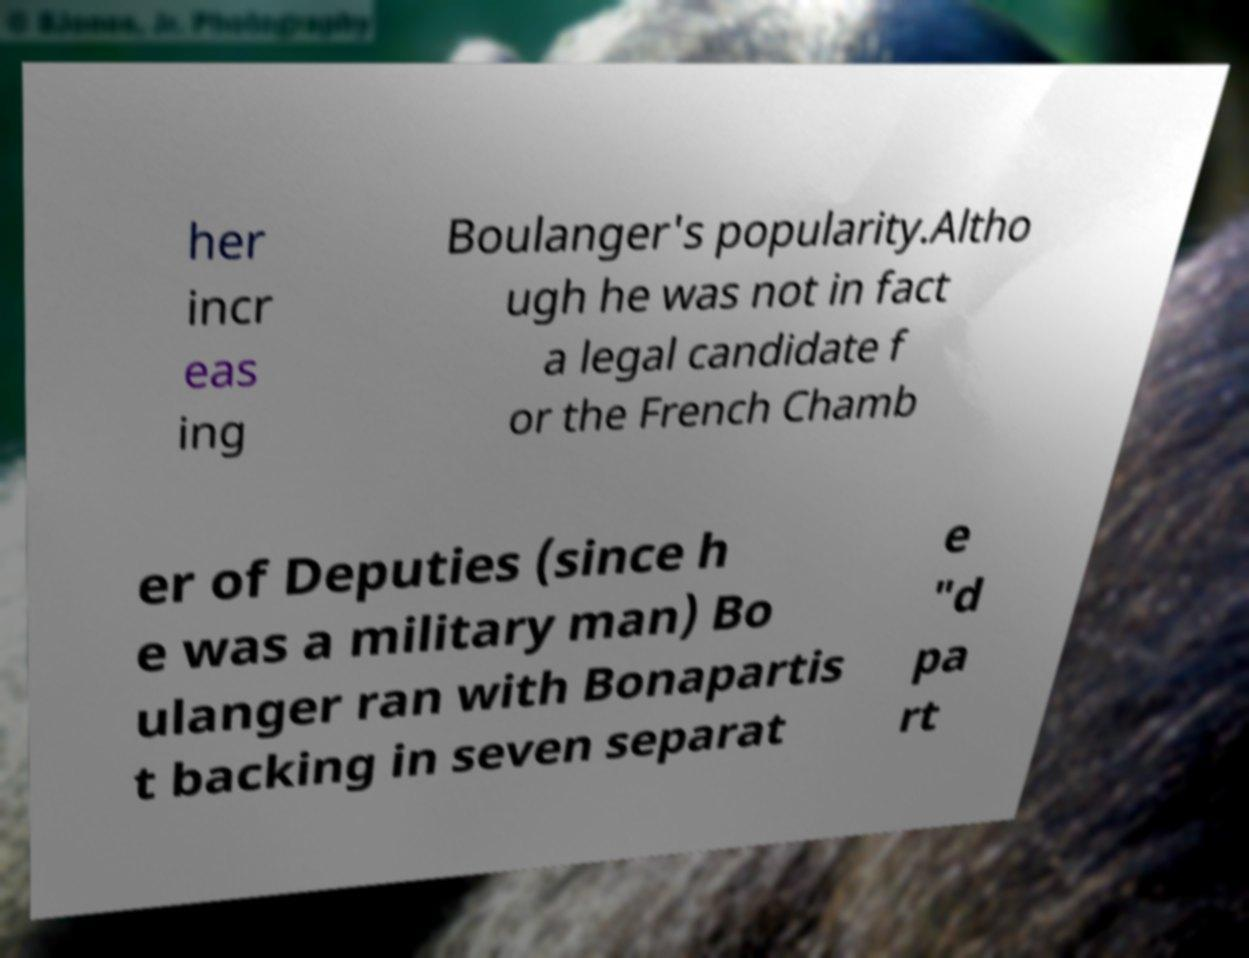What messages or text are displayed in this image? I need them in a readable, typed format. her incr eas ing Boulanger's popularity.Altho ugh he was not in fact a legal candidate f or the French Chamb er of Deputies (since h e was a military man) Bo ulanger ran with Bonapartis t backing in seven separat e "d pa rt 